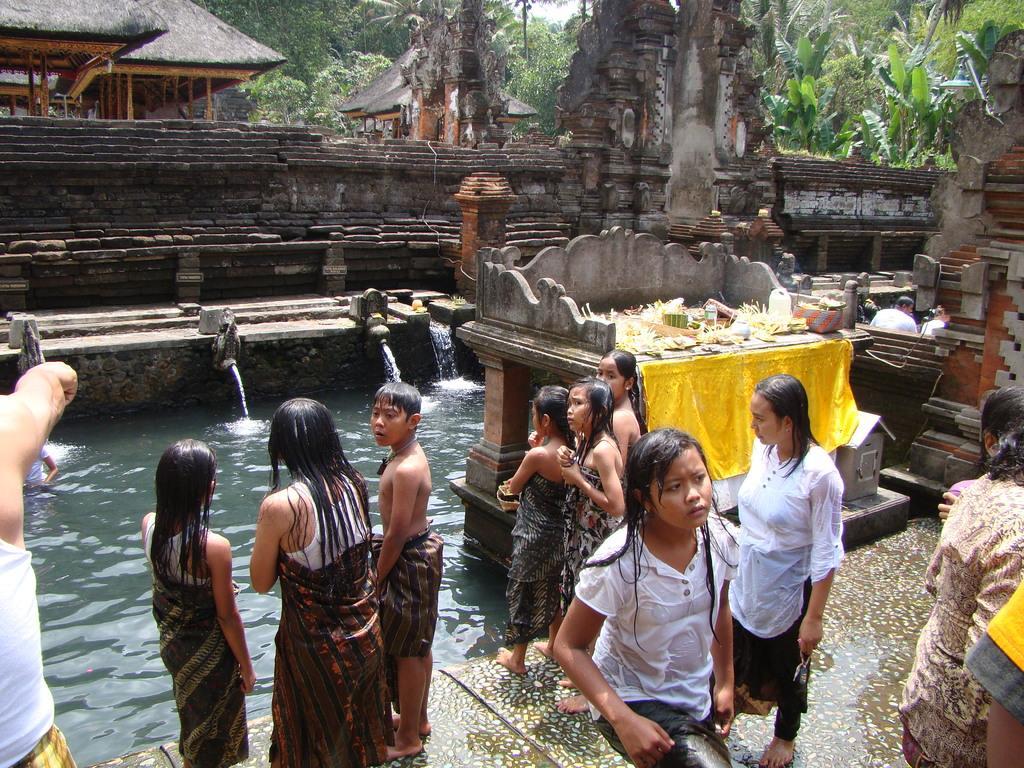How would you summarize this image in a sentence or two? In this image we can see a monument and some houses with roof. On the bottom of the image we can see a memorial and some people standing beside a lake. On the backside we can see a group of trees and the sky. 